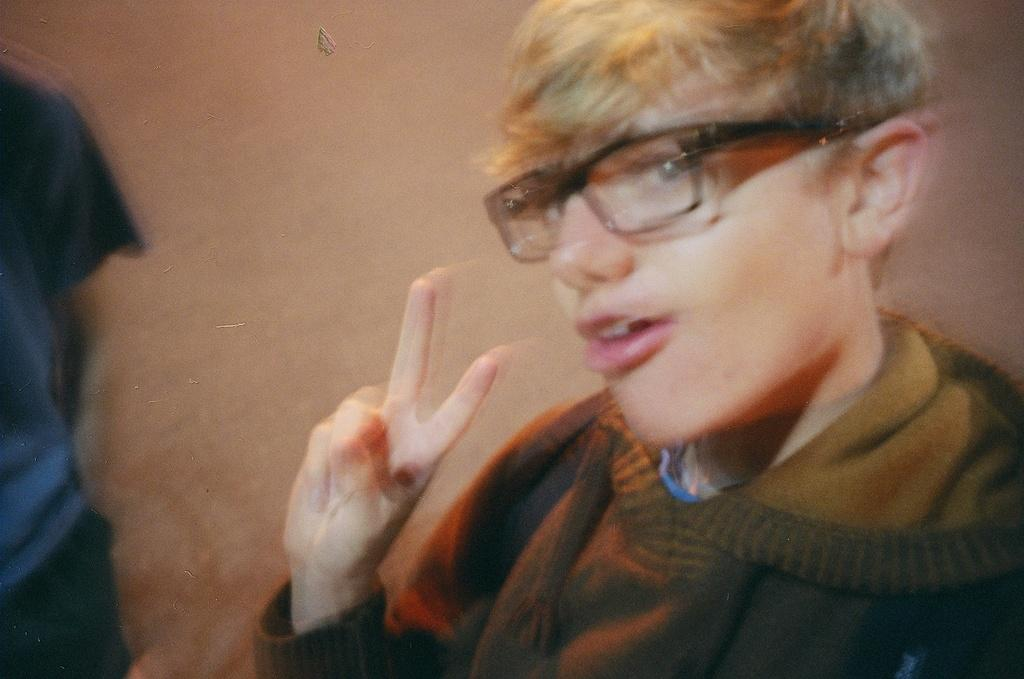Who is the main subject in the picture? There is a boy in the picture. What is the boy wearing in the image? The boy is wearing a brown jacket. What is the boy doing in the picture? The boy is standing in front of the camera and giving a pose to the camera. What can be seen in the background of the picture? There is a brown wall in the background of the picture. What type of ink is the boy using to write on the wall in the image? There is no ink or writing on the wall in the image; the boy is simply standing in front of a brown wall. 